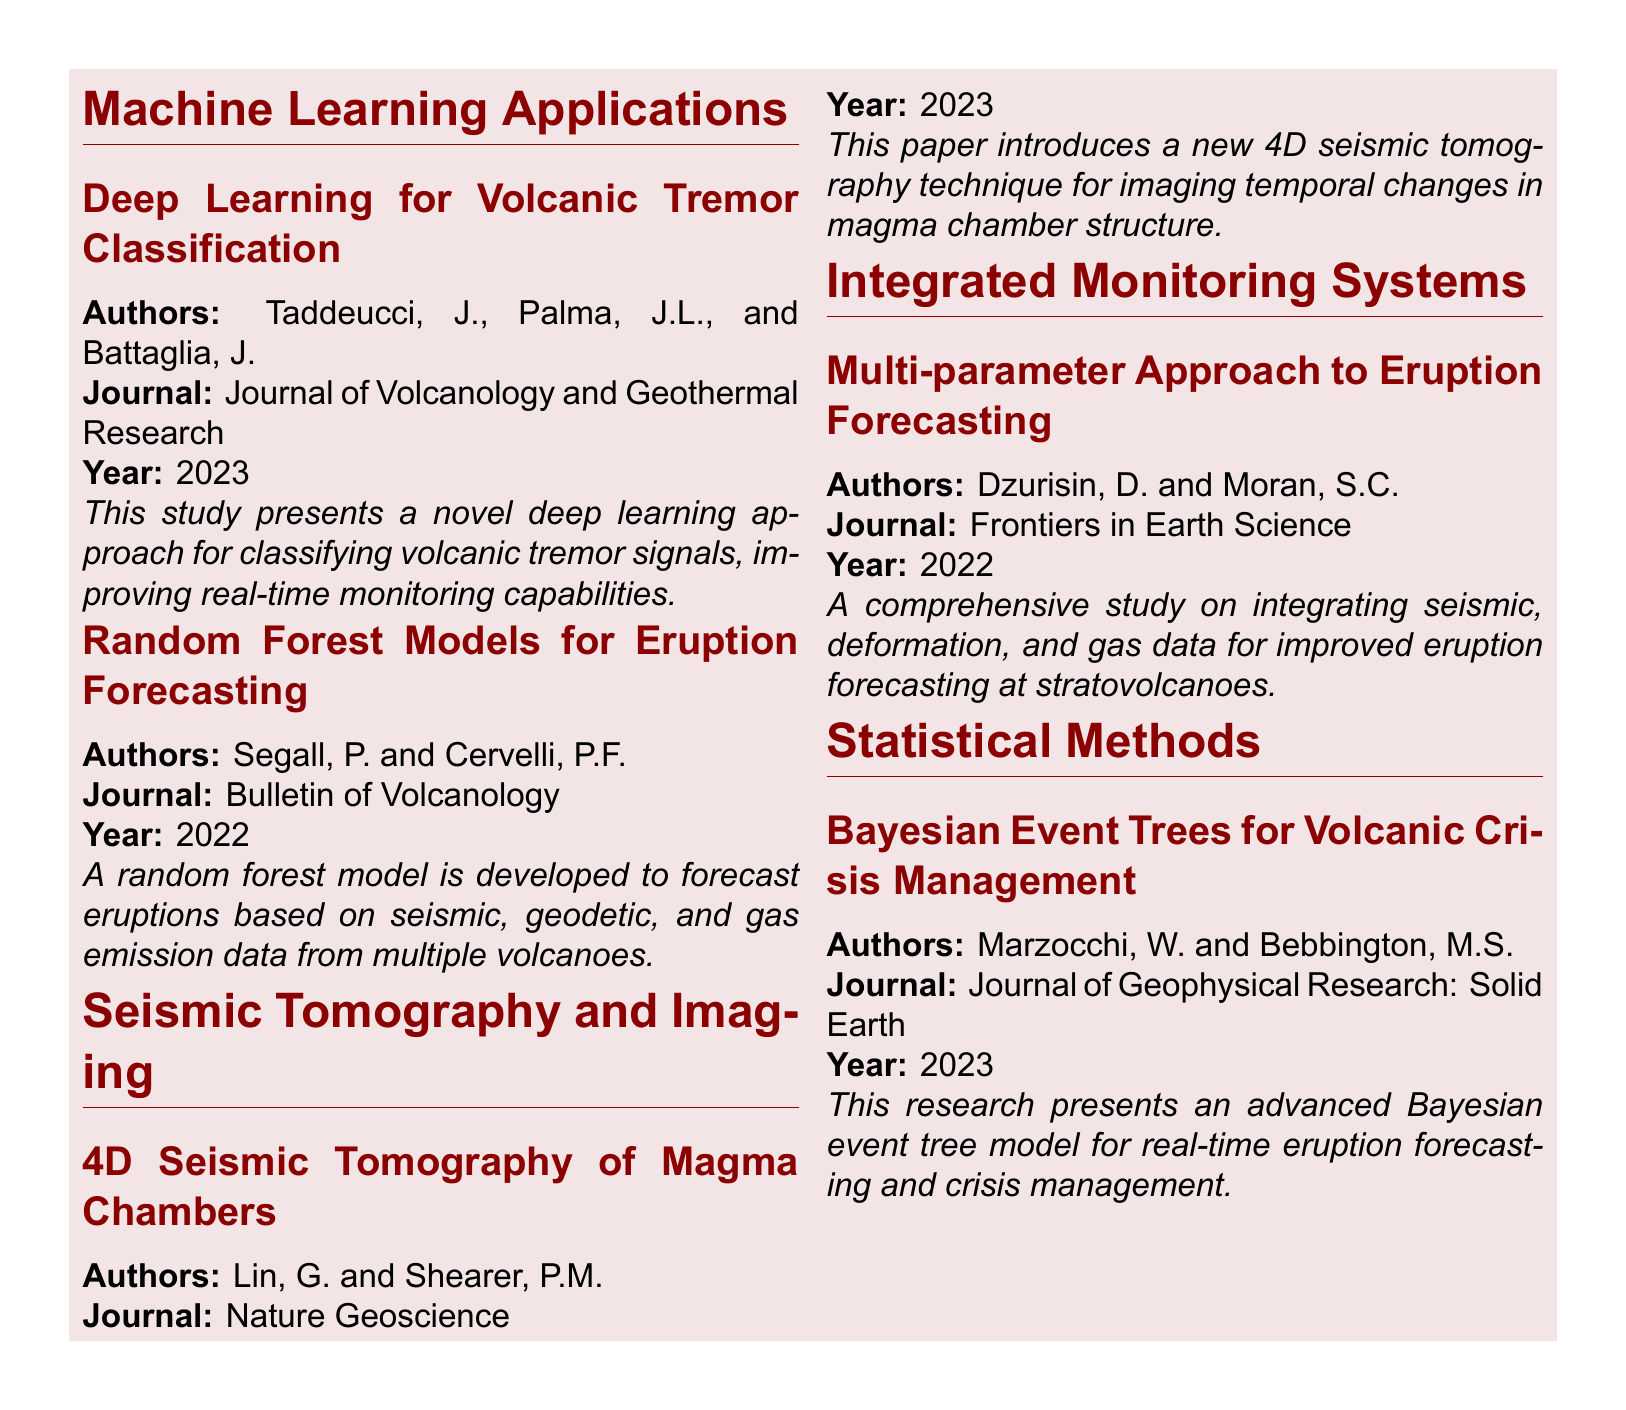What is the title of the document? The title provided at the top of the document indicates the main theme or focus of the content, which is about advancements in volcano-seismic forecasting techniques.
Answer: Recent Advances in Volcano-Seismic Forecasting Techniques Who are the authors of the study on deep learning for volcanic tremor classification? The question asks for the names of the authors referenced in the document under the section for machine learning applications, specifically about volcanic tremor classification.
Answer: Taddeucci, J., Palma, J.L., and Battaglia, J In which journal is the random forest model study published? This inquiry seeks to identify the publication outlet for the research paper on eruption forecasting, as cited in the document.
Answer: Bulletin of Volcanology What year was the 4D seismic tomography of magma chambers published? The question asks for the publication year of the specific research regarding magma chambers, which reflects the recency of the advancements discussed.
Answer: 2023 What is the research focus of Marzocchi and Bebbington's paper? The question requires an understanding of the core topic of the study by Marzocchi and Bebbington, highlighting its application in the field of volcanic crisis management.
Answer: Bayesian event trees for volcanic crisis management Which publication features the multi-parameter approach to eruption forecasting? This question targets the specific journal where the comprehensive study on integrated eruption forecasting methods was showcased, as noted in the document.
Answer: Frontiers in Earth Science 